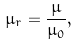<formula> <loc_0><loc_0><loc_500><loc_500>\mu _ { r } = { \frac { \mu } { \mu _ { 0 } } } ,</formula> 